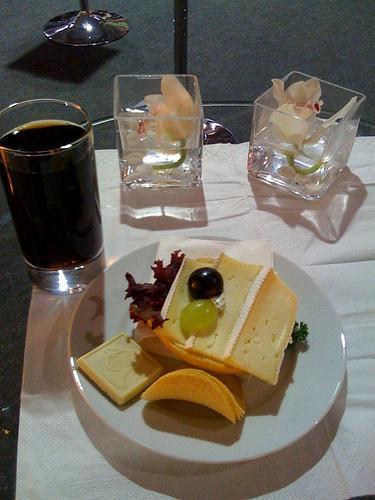How many green grapes are on the plate?
Give a very brief answer. 1. How many glasses are half full?
Give a very brief answer. 2. How many cups?
Give a very brief answer. 3. How many vases are there?
Give a very brief answer. 2. How many cups can you see?
Give a very brief answer. 2. How many cakes are there?
Give a very brief answer. 1. 